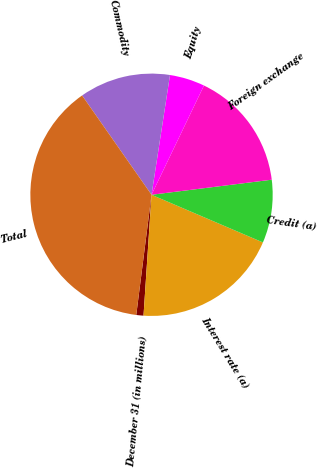Convert chart to OTSL. <chart><loc_0><loc_0><loc_500><loc_500><pie_chart><fcel>December 31 (in millions)<fcel>Interest rate (a)<fcel>Credit (a)<fcel>Foreign exchange<fcel>Equity<fcel>Commodity<fcel>Total<nl><fcel>0.96%<fcel>19.62%<fcel>8.42%<fcel>15.89%<fcel>4.69%<fcel>12.15%<fcel>38.28%<nl></chart> 